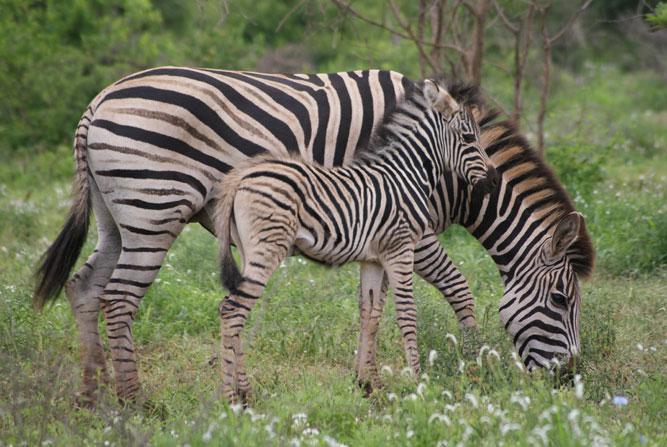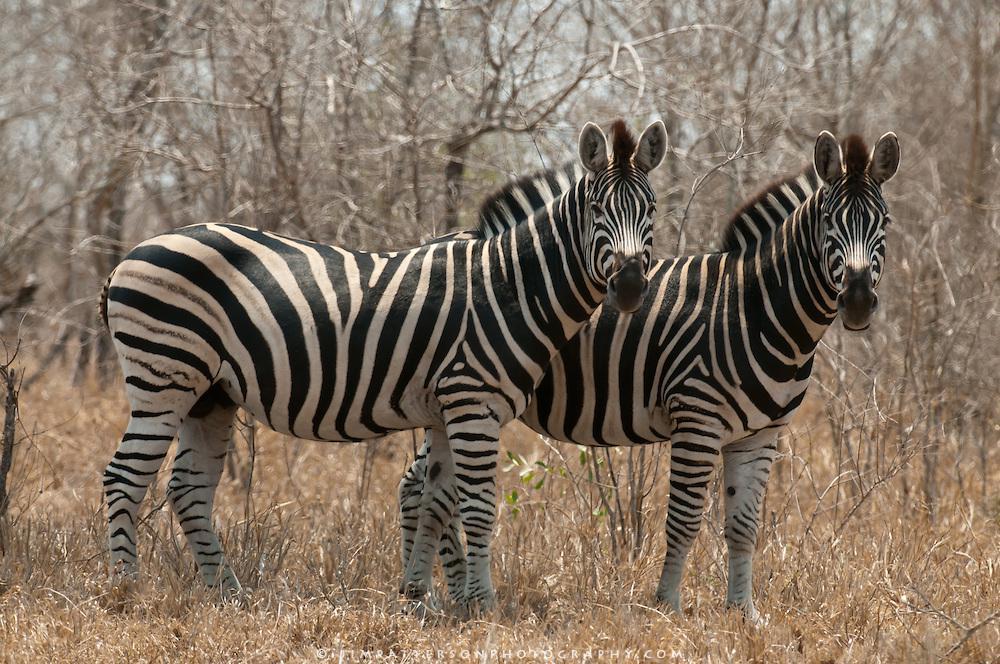The first image is the image on the left, the second image is the image on the right. For the images shown, is this caption "Exactly one zebra is grazing." true? Answer yes or no. Yes. The first image is the image on the left, the second image is the image on the right. Given the left and right images, does the statement "The right image contains no more than two zebras." hold true? Answer yes or no. Yes. 